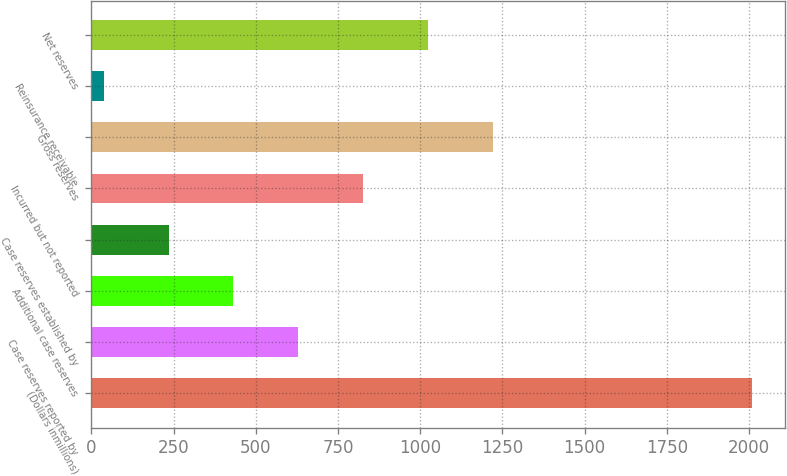<chart> <loc_0><loc_0><loc_500><loc_500><bar_chart><fcel>(Dollars inmillions)<fcel>Case reserves reported by<fcel>Additional case reserves<fcel>Case reserves established by<fcel>Incurred but not reported<fcel>Gross reserves<fcel>Reinsurance receivable<fcel>Net reserves<nl><fcel>2008<fcel>628.79<fcel>431.76<fcel>234.73<fcel>825.82<fcel>1219.88<fcel>37.7<fcel>1022.85<nl></chart> 